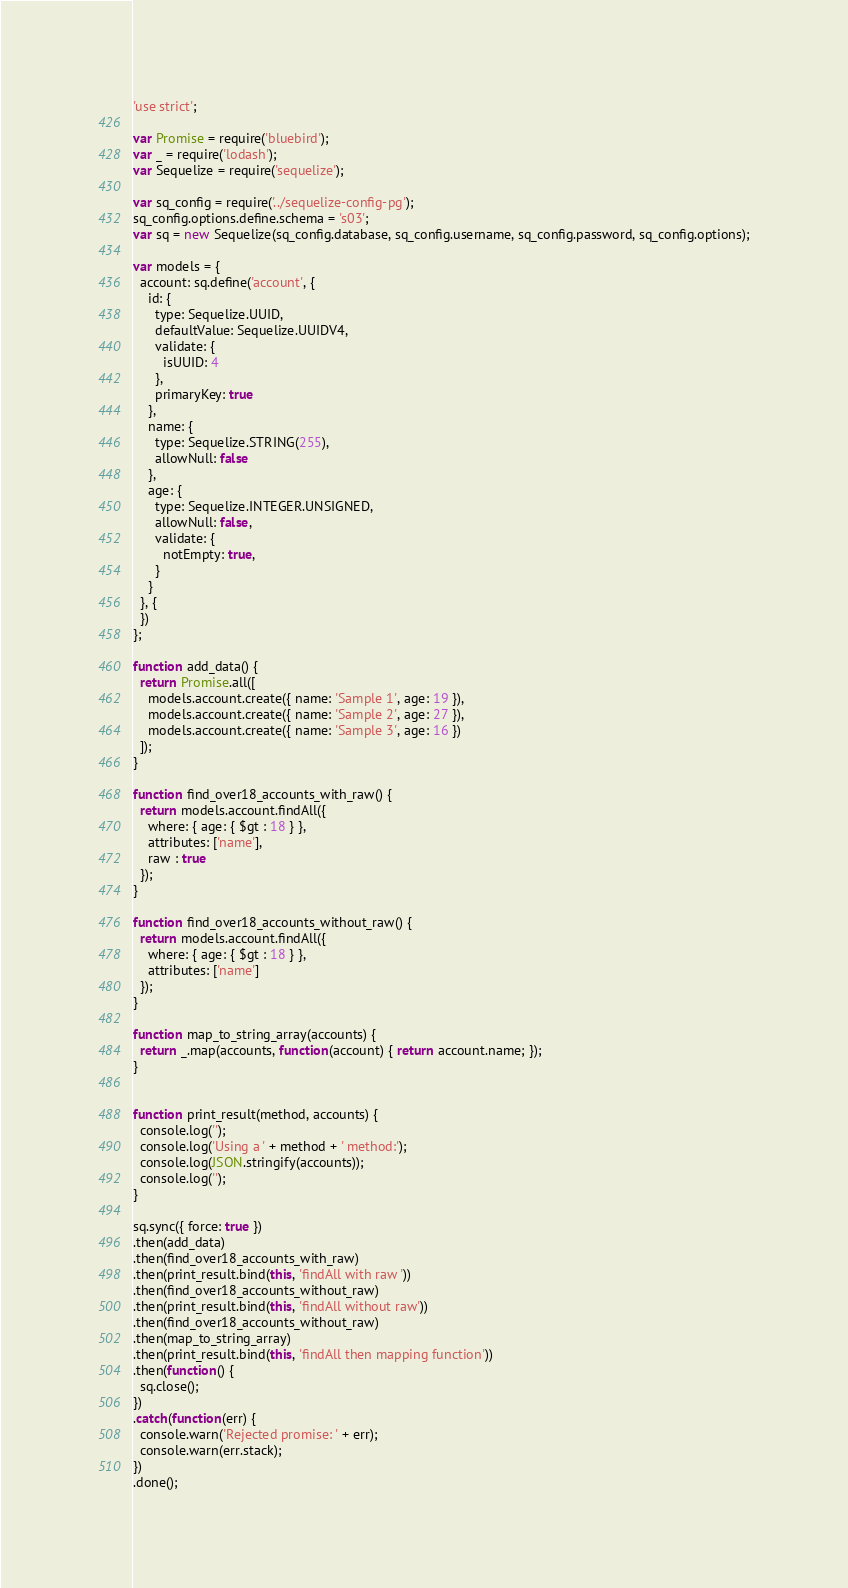<code> <loc_0><loc_0><loc_500><loc_500><_JavaScript_>'use strict';

var Promise = require('bluebird');
var _ = require('lodash');
var Sequelize = require('sequelize');

var sq_config = require('../sequelize-config-pg');
sq_config.options.define.schema = 's03';
var sq = new Sequelize(sq_config.database, sq_config.username, sq_config.password, sq_config.options);

var models = {
  account: sq.define('account', {
    id: {
      type: Sequelize.UUID,
      defaultValue: Sequelize.UUIDV4,
      validate: {
        isUUID: 4
      },
      primaryKey: true
    },
    name: {
      type: Sequelize.STRING(255),
      allowNull: false
    },
    age: {
      type: Sequelize.INTEGER.UNSIGNED,
      allowNull: false,
      validate: {
        notEmpty: true,
      }
    }
  }, {
  })
};

function add_data() {
  return Promise.all([
    models.account.create({ name: 'Sample 1', age: 19 }),
    models.account.create({ name: 'Sample 2', age: 27 }),
    models.account.create({ name: 'Sample 3', age: 16 })
  ]);
}

function find_over18_accounts_with_raw() {
  return models.account.findAll({
    where: { age: { $gt : 18 } },
    attributes: ['name'],
    raw : true
  });
}

function find_over18_accounts_without_raw() {
  return models.account.findAll({
    where: { age: { $gt : 18 } },
    attributes: ['name']
  });
}

function map_to_string_array(accounts) {
  return _.map(accounts, function(account) { return account.name; });
}


function print_result(method, accounts) {
  console.log('');
  console.log('Using a ' + method + ' method:');
  console.log(JSON.stringify(accounts));
  console.log('');
}

sq.sync({ force: true })
.then(add_data)
.then(find_over18_accounts_with_raw)
.then(print_result.bind(this, 'findAll with raw '))
.then(find_over18_accounts_without_raw)
.then(print_result.bind(this, 'findAll without raw'))
.then(find_over18_accounts_without_raw)
.then(map_to_string_array)
.then(print_result.bind(this, 'findAll then mapping function'))
.then(function() {
  sq.close();
})
.catch(function(err) {
  console.warn('Rejected promise: ' + err);
  console.warn(err.stack);
})
.done();
</code> 